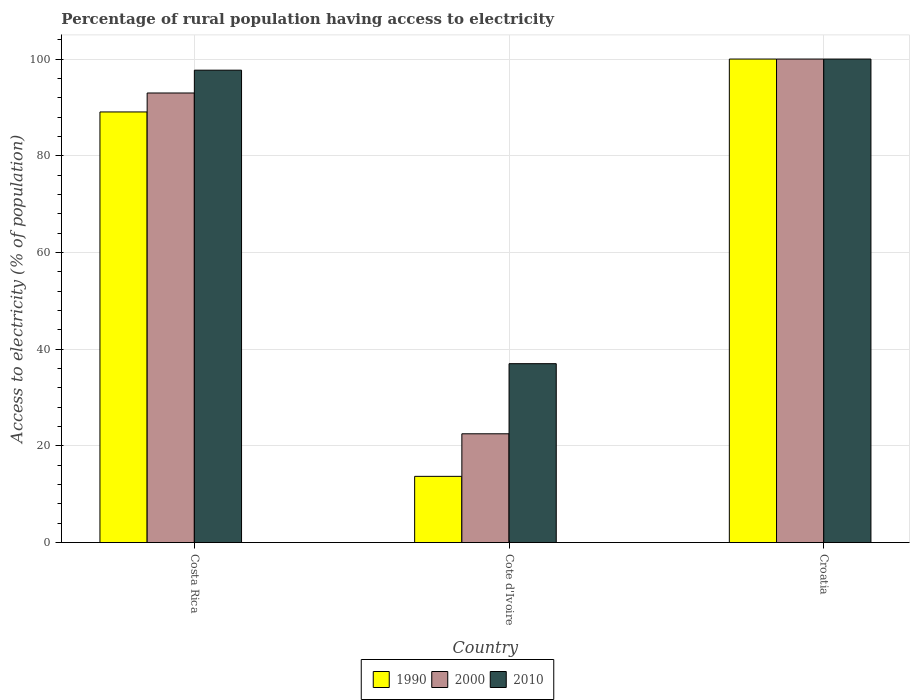How many different coloured bars are there?
Give a very brief answer. 3. Are the number of bars per tick equal to the number of legend labels?
Your answer should be compact. Yes. Are the number of bars on each tick of the X-axis equal?
Give a very brief answer. Yes. How many bars are there on the 3rd tick from the left?
Your answer should be compact. 3. What is the label of the 2nd group of bars from the left?
Provide a short and direct response. Cote d'Ivoire. What is the percentage of rural population having access to electricity in 2000 in Costa Rica?
Provide a succinct answer. 92.98. Across all countries, what is the maximum percentage of rural population having access to electricity in 2000?
Provide a short and direct response. 100. Across all countries, what is the minimum percentage of rural population having access to electricity in 1990?
Keep it short and to the point. 13.7. In which country was the percentage of rural population having access to electricity in 1990 maximum?
Give a very brief answer. Croatia. In which country was the percentage of rural population having access to electricity in 2010 minimum?
Give a very brief answer. Cote d'Ivoire. What is the total percentage of rural population having access to electricity in 2010 in the graph?
Give a very brief answer. 234.7. What is the difference between the percentage of rural population having access to electricity in 1990 in Cote d'Ivoire and that in Croatia?
Provide a short and direct response. -86.3. What is the difference between the percentage of rural population having access to electricity in 2010 in Croatia and the percentage of rural population having access to electricity in 1990 in Costa Rica?
Offer a very short reply. 10.94. What is the average percentage of rural population having access to electricity in 1990 per country?
Your answer should be very brief. 67.59. What is the difference between the percentage of rural population having access to electricity of/in 2010 and percentage of rural population having access to electricity of/in 1990 in Costa Rica?
Make the answer very short. 8.64. In how many countries, is the percentage of rural population having access to electricity in 1990 greater than 48 %?
Offer a very short reply. 2. What is the ratio of the percentage of rural population having access to electricity in 1990 in Costa Rica to that in Cote d'Ivoire?
Make the answer very short. 6.5. Is the difference between the percentage of rural population having access to electricity in 2010 in Cote d'Ivoire and Croatia greater than the difference between the percentage of rural population having access to electricity in 1990 in Cote d'Ivoire and Croatia?
Make the answer very short. Yes. What is the difference between the highest and the second highest percentage of rural population having access to electricity in 1990?
Offer a very short reply. -10.94. In how many countries, is the percentage of rural population having access to electricity in 2010 greater than the average percentage of rural population having access to electricity in 2010 taken over all countries?
Make the answer very short. 2. Are the values on the major ticks of Y-axis written in scientific E-notation?
Keep it short and to the point. No. Where does the legend appear in the graph?
Your response must be concise. Bottom center. What is the title of the graph?
Your response must be concise. Percentage of rural population having access to electricity. Does "1970" appear as one of the legend labels in the graph?
Make the answer very short. No. What is the label or title of the X-axis?
Your answer should be compact. Country. What is the label or title of the Y-axis?
Your answer should be compact. Access to electricity (% of population). What is the Access to electricity (% of population) of 1990 in Costa Rica?
Your response must be concise. 89.06. What is the Access to electricity (% of population) in 2000 in Costa Rica?
Ensure brevity in your answer.  92.98. What is the Access to electricity (% of population) of 2010 in Costa Rica?
Make the answer very short. 97.7. What is the Access to electricity (% of population) of 1990 in Cote d'Ivoire?
Keep it short and to the point. 13.7. What is the Access to electricity (% of population) of 1990 in Croatia?
Keep it short and to the point. 100. What is the Access to electricity (% of population) in 2000 in Croatia?
Your answer should be very brief. 100. Across all countries, what is the maximum Access to electricity (% of population) of 1990?
Ensure brevity in your answer.  100. Across all countries, what is the maximum Access to electricity (% of population) in 2000?
Your answer should be compact. 100. Across all countries, what is the maximum Access to electricity (% of population) in 2010?
Provide a short and direct response. 100. Across all countries, what is the minimum Access to electricity (% of population) of 2000?
Your answer should be very brief. 22.5. Across all countries, what is the minimum Access to electricity (% of population) of 2010?
Your answer should be compact. 37. What is the total Access to electricity (% of population) in 1990 in the graph?
Your response must be concise. 202.76. What is the total Access to electricity (% of population) of 2000 in the graph?
Offer a terse response. 215.48. What is the total Access to electricity (% of population) of 2010 in the graph?
Keep it short and to the point. 234.7. What is the difference between the Access to electricity (% of population) in 1990 in Costa Rica and that in Cote d'Ivoire?
Keep it short and to the point. 75.36. What is the difference between the Access to electricity (% of population) in 2000 in Costa Rica and that in Cote d'Ivoire?
Make the answer very short. 70.48. What is the difference between the Access to electricity (% of population) of 2010 in Costa Rica and that in Cote d'Ivoire?
Provide a succinct answer. 60.7. What is the difference between the Access to electricity (% of population) of 1990 in Costa Rica and that in Croatia?
Your answer should be very brief. -10.94. What is the difference between the Access to electricity (% of population) in 2000 in Costa Rica and that in Croatia?
Provide a succinct answer. -7.02. What is the difference between the Access to electricity (% of population) of 1990 in Cote d'Ivoire and that in Croatia?
Offer a very short reply. -86.3. What is the difference between the Access to electricity (% of population) in 2000 in Cote d'Ivoire and that in Croatia?
Provide a short and direct response. -77.5. What is the difference between the Access to electricity (% of population) of 2010 in Cote d'Ivoire and that in Croatia?
Offer a terse response. -63. What is the difference between the Access to electricity (% of population) of 1990 in Costa Rica and the Access to electricity (% of population) of 2000 in Cote d'Ivoire?
Make the answer very short. 66.56. What is the difference between the Access to electricity (% of population) in 1990 in Costa Rica and the Access to electricity (% of population) in 2010 in Cote d'Ivoire?
Make the answer very short. 52.06. What is the difference between the Access to electricity (% of population) of 2000 in Costa Rica and the Access to electricity (% of population) of 2010 in Cote d'Ivoire?
Ensure brevity in your answer.  55.98. What is the difference between the Access to electricity (% of population) of 1990 in Costa Rica and the Access to electricity (% of population) of 2000 in Croatia?
Offer a terse response. -10.94. What is the difference between the Access to electricity (% of population) of 1990 in Costa Rica and the Access to electricity (% of population) of 2010 in Croatia?
Offer a terse response. -10.94. What is the difference between the Access to electricity (% of population) of 2000 in Costa Rica and the Access to electricity (% of population) of 2010 in Croatia?
Offer a very short reply. -7.02. What is the difference between the Access to electricity (% of population) in 1990 in Cote d'Ivoire and the Access to electricity (% of population) in 2000 in Croatia?
Provide a succinct answer. -86.3. What is the difference between the Access to electricity (% of population) of 1990 in Cote d'Ivoire and the Access to electricity (% of population) of 2010 in Croatia?
Provide a short and direct response. -86.3. What is the difference between the Access to electricity (% of population) in 2000 in Cote d'Ivoire and the Access to electricity (% of population) in 2010 in Croatia?
Your answer should be very brief. -77.5. What is the average Access to electricity (% of population) of 1990 per country?
Your response must be concise. 67.59. What is the average Access to electricity (% of population) of 2000 per country?
Offer a terse response. 71.83. What is the average Access to electricity (% of population) of 2010 per country?
Provide a short and direct response. 78.23. What is the difference between the Access to electricity (% of population) in 1990 and Access to electricity (% of population) in 2000 in Costa Rica?
Make the answer very short. -3.92. What is the difference between the Access to electricity (% of population) in 1990 and Access to electricity (% of population) in 2010 in Costa Rica?
Give a very brief answer. -8.64. What is the difference between the Access to electricity (% of population) of 2000 and Access to electricity (% of population) of 2010 in Costa Rica?
Your answer should be very brief. -4.72. What is the difference between the Access to electricity (% of population) of 1990 and Access to electricity (% of population) of 2010 in Cote d'Ivoire?
Give a very brief answer. -23.3. What is the difference between the Access to electricity (% of population) of 1990 and Access to electricity (% of population) of 2010 in Croatia?
Provide a succinct answer. 0. What is the ratio of the Access to electricity (% of population) in 1990 in Costa Rica to that in Cote d'Ivoire?
Offer a very short reply. 6.5. What is the ratio of the Access to electricity (% of population) of 2000 in Costa Rica to that in Cote d'Ivoire?
Offer a very short reply. 4.13. What is the ratio of the Access to electricity (% of population) of 2010 in Costa Rica to that in Cote d'Ivoire?
Provide a succinct answer. 2.64. What is the ratio of the Access to electricity (% of population) in 1990 in Costa Rica to that in Croatia?
Your answer should be very brief. 0.89. What is the ratio of the Access to electricity (% of population) of 2000 in Costa Rica to that in Croatia?
Your answer should be very brief. 0.93. What is the ratio of the Access to electricity (% of population) in 2010 in Costa Rica to that in Croatia?
Provide a short and direct response. 0.98. What is the ratio of the Access to electricity (% of population) in 1990 in Cote d'Ivoire to that in Croatia?
Provide a succinct answer. 0.14. What is the ratio of the Access to electricity (% of population) of 2000 in Cote d'Ivoire to that in Croatia?
Your answer should be very brief. 0.23. What is the ratio of the Access to electricity (% of population) in 2010 in Cote d'Ivoire to that in Croatia?
Provide a succinct answer. 0.37. What is the difference between the highest and the second highest Access to electricity (% of population) in 1990?
Keep it short and to the point. 10.94. What is the difference between the highest and the second highest Access to electricity (% of population) of 2000?
Provide a succinct answer. 7.02. What is the difference between the highest and the lowest Access to electricity (% of population) in 1990?
Provide a succinct answer. 86.3. What is the difference between the highest and the lowest Access to electricity (% of population) of 2000?
Your response must be concise. 77.5. What is the difference between the highest and the lowest Access to electricity (% of population) in 2010?
Ensure brevity in your answer.  63. 